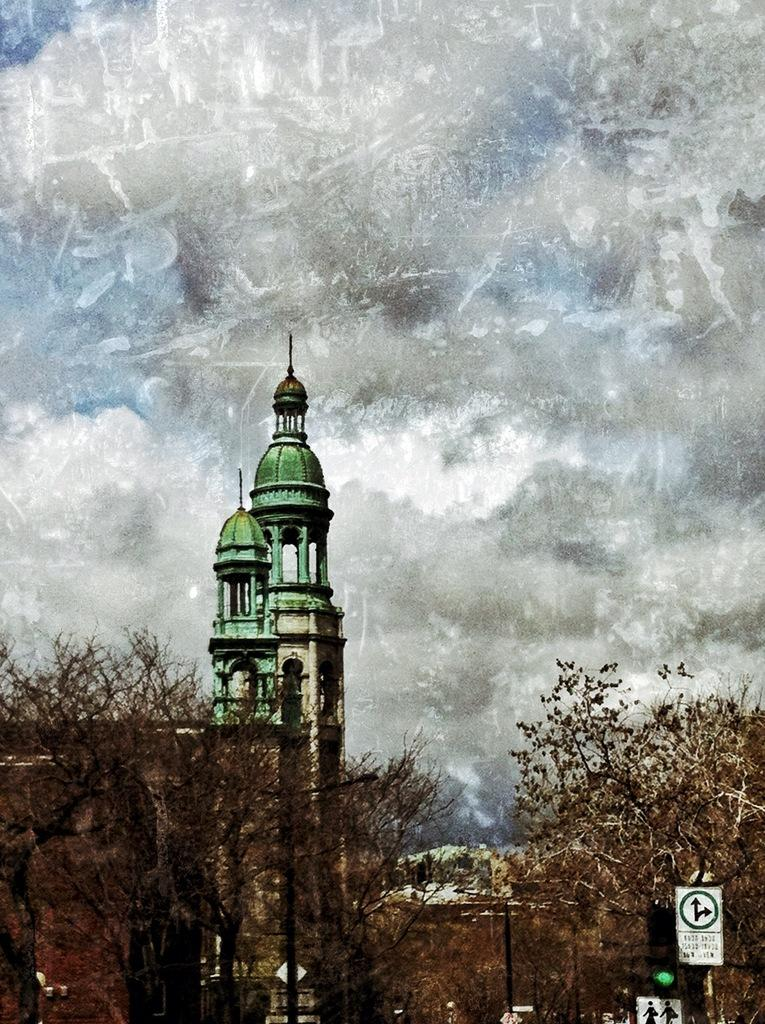What structures are visible in the image? There are towers, buildings, and a traffic signal in the image. What type of vegetation can be seen in the image? There are trees in the image. What can be found in the foreground of the image? There are sign boards and a traffic signal in the foreground of the image. How would you describe the sky in the image? The sky is cloudy in the image. What type of pump is used to draw water from the well in the image? There is no well or pump present in the image. What color is the notebook on the table in the image? There is no notebook present in the image. 